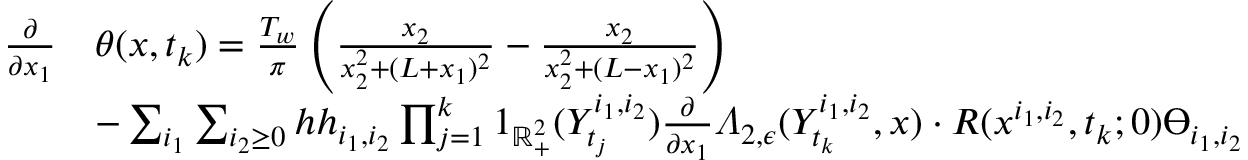Convert formula to latex. <formula><loc_0><loc_0><loc_500><loc_500>\begin{array} { r l } { \frac { \partial } { \partial x _ { 1 } } } & { \theta ( x , t _ { k } ) = \frac { T _ { w } } { \pi } \left ( \frac { x _ { 2 } } { x _ { 2 } ^ { 2 } + ( L + x _ { 1 } ) ^ { 2 } } - \frac { x _ { 2 } } { x _ { 2 } ^ { 2 } + ( L - x _ { 1 } ) ^ { 2 } } \right ) } \\ & { - \sum _ { i _ { 1 } } \sum _ { i _ { 2 } \geq 0 } h h _ { i _ { 1 } , i _ { 2 } } \prod _ { j = 1 } ^ { k } 1 _ { \mathbb { R } _ { + } ^ { 2 } } ( Y _ { t _ { j } } ^ { i _ { 1 } , i _ { 2 } } ) \frac { \partial } { \partial x _ { 1 } } \varLambda _ { 2 , \epsilon } ( Y _ { t _ { k } } ^ { i _ { 1 } , i _ { 2 } } , x ) \cdot R ( x ^ { i _ { 1 } , i _ { 2 } } , t _ { k } ; 0 ) \varTheta _ { i _ { 1 } , i _ { 2 } } } \end{array}</formula> 